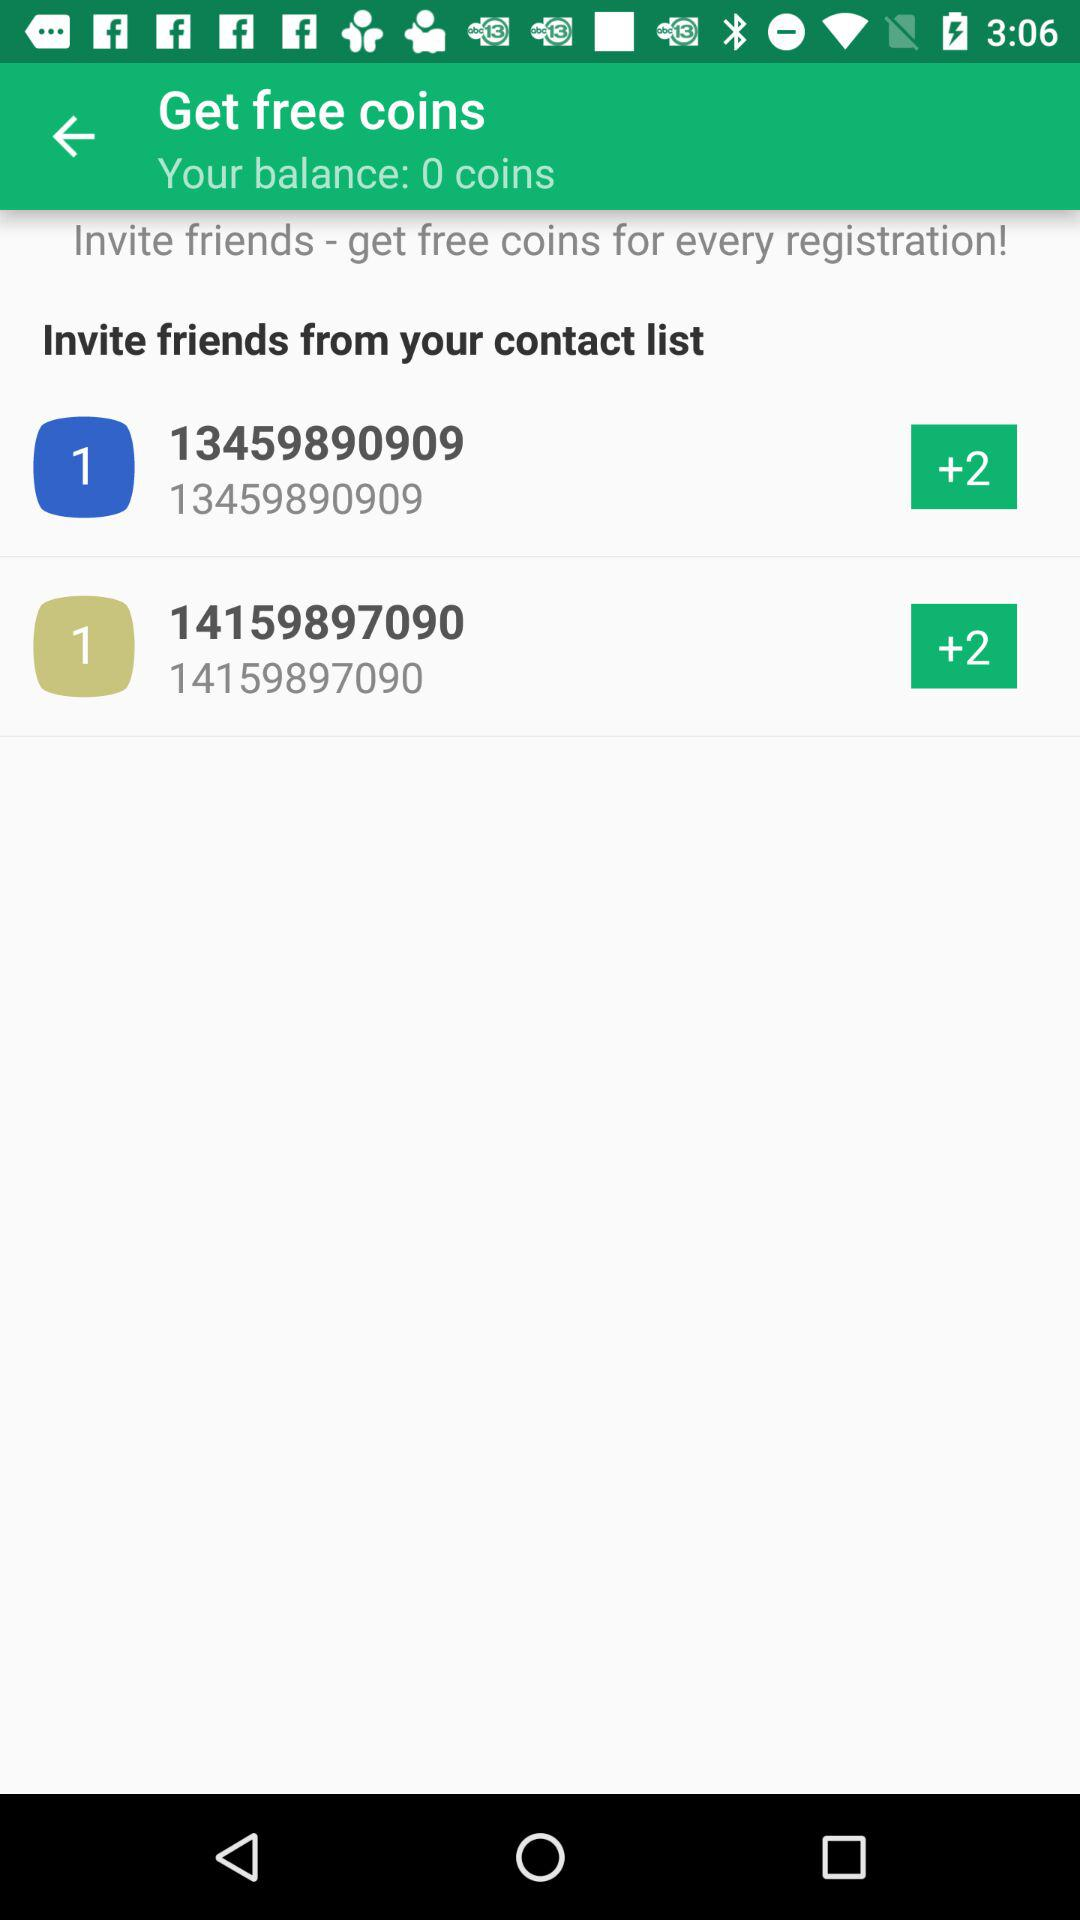What is the total coin balance? The total coin balance is 0. 